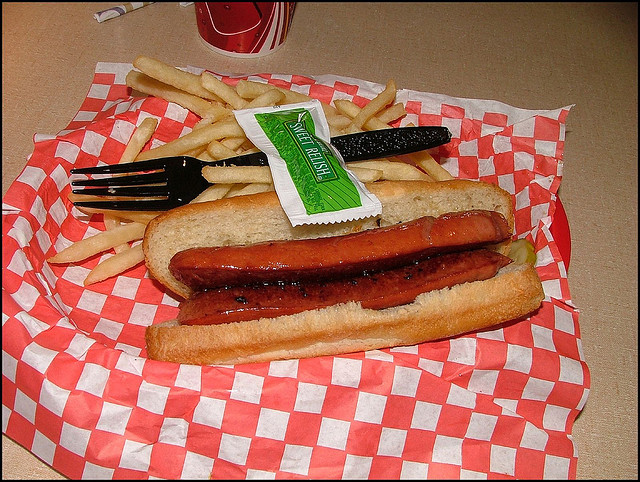Identify the text displayed in this image. RELISH SWEET 